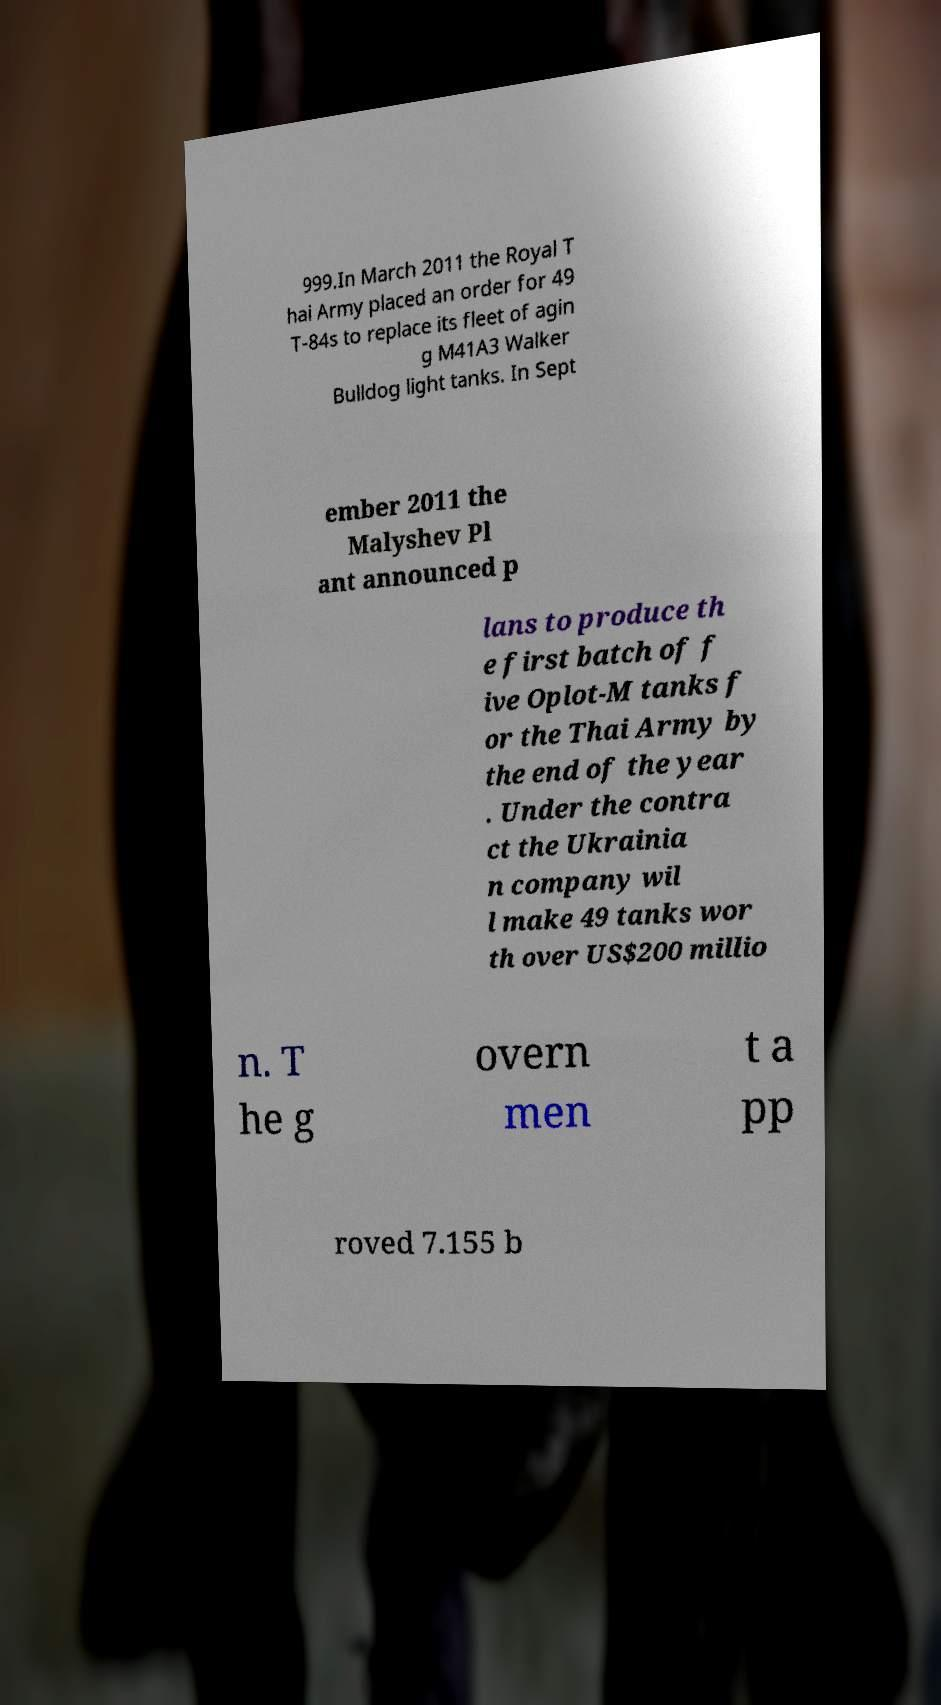Please read and relay the text visible in this image. What does it say? 999.In March 2011 the Royal T hai Army placed an order for 49 T-84s to replace its fleet of agin g M41A3 Walker Bulldog light tanks. In Sept ember 2011 the Malyshev Pl ant announced p lans to produce th e first batch of f ive Oplot-M tanks f or the Thai Army by the end of the year . Under the contra ct the Ukrainia n company wil l make 49 tanks wor th over US$200 millio n. T he g overn men t a pp roved 7.155 b 